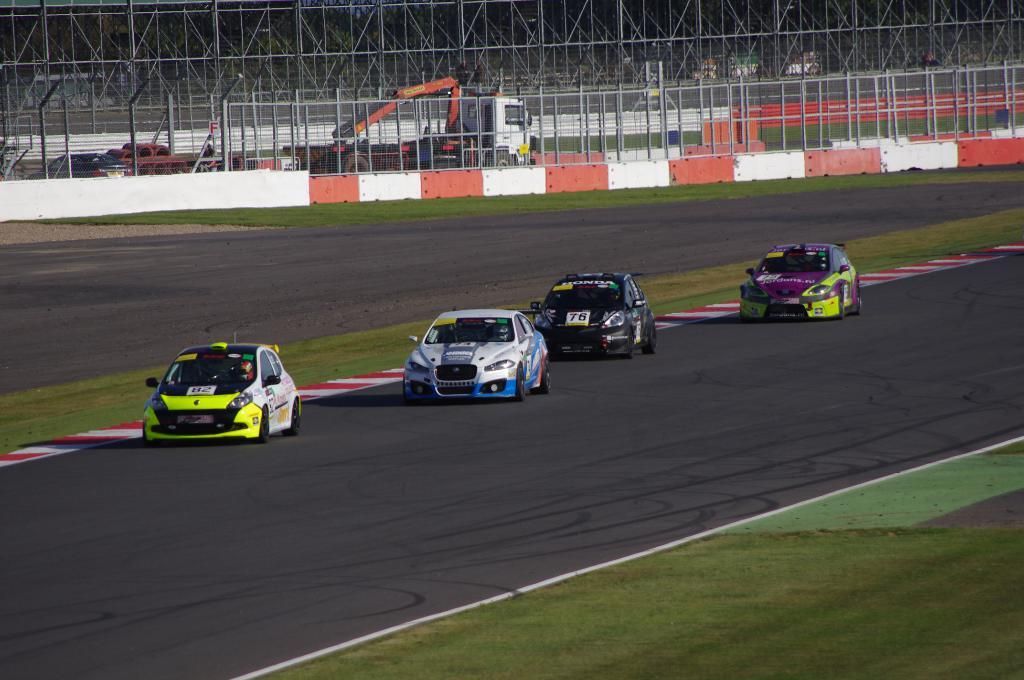What is happening in the foreground of the picture? Cars are moving on the road in the foreground of the picture. What can be seen in the center of the picture? There is fencing, vehicles, grass, and a wall in the center of the picture. Is there any fencing visible in the picture? Yes, there is fencing in the center and at the top of the picture. What type of surface is visible in the center of the picture? There is grass in the center of the picture. What type of celery can be seen growing in the center of the picture? There is no celery present in the image; it features cars, fencing, vehicles, grass, and a wall. What experience can be gained from observing the vehicles in the center of the picture? The image does not convey any specific experience or emotion; it simply depicts the scene. 